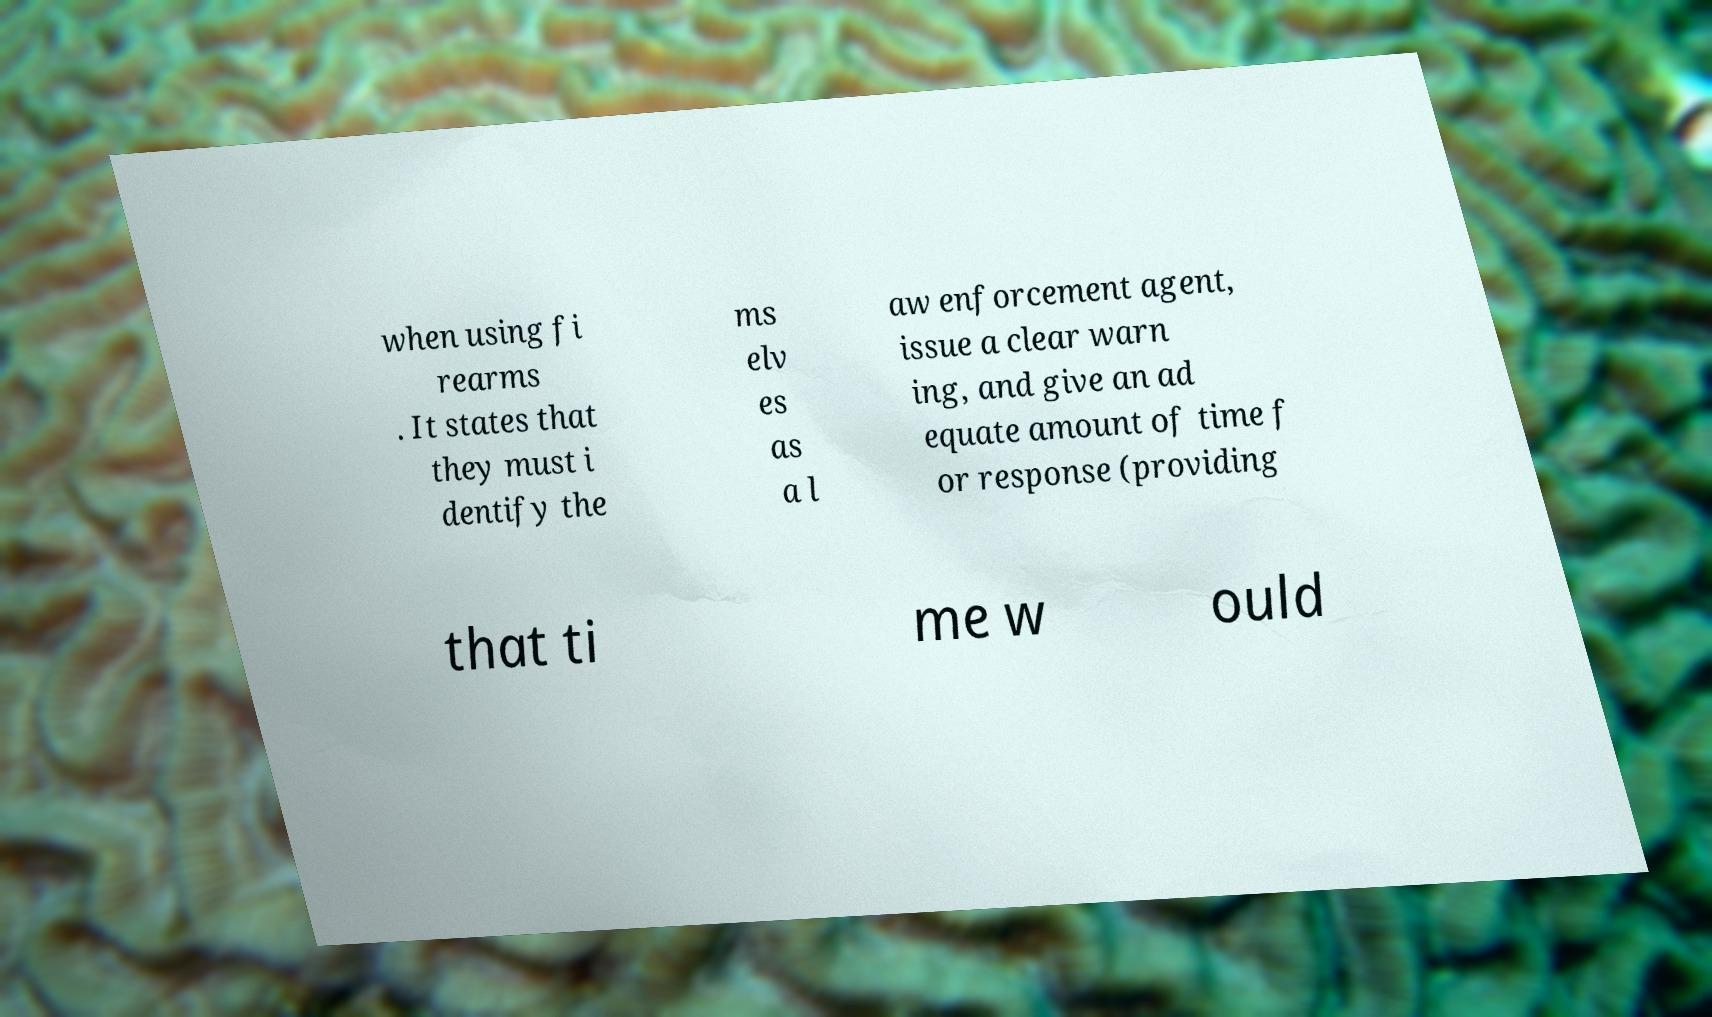For documentation purposes, I need the text within this image transcribed. Could you provide that? when using fi rearms . It states that they must i dentify the ms elv es as a l aw enforcement agent, issue a clear warn ing, and give an ad equate amount of time f or response (providing that ti me w ould 